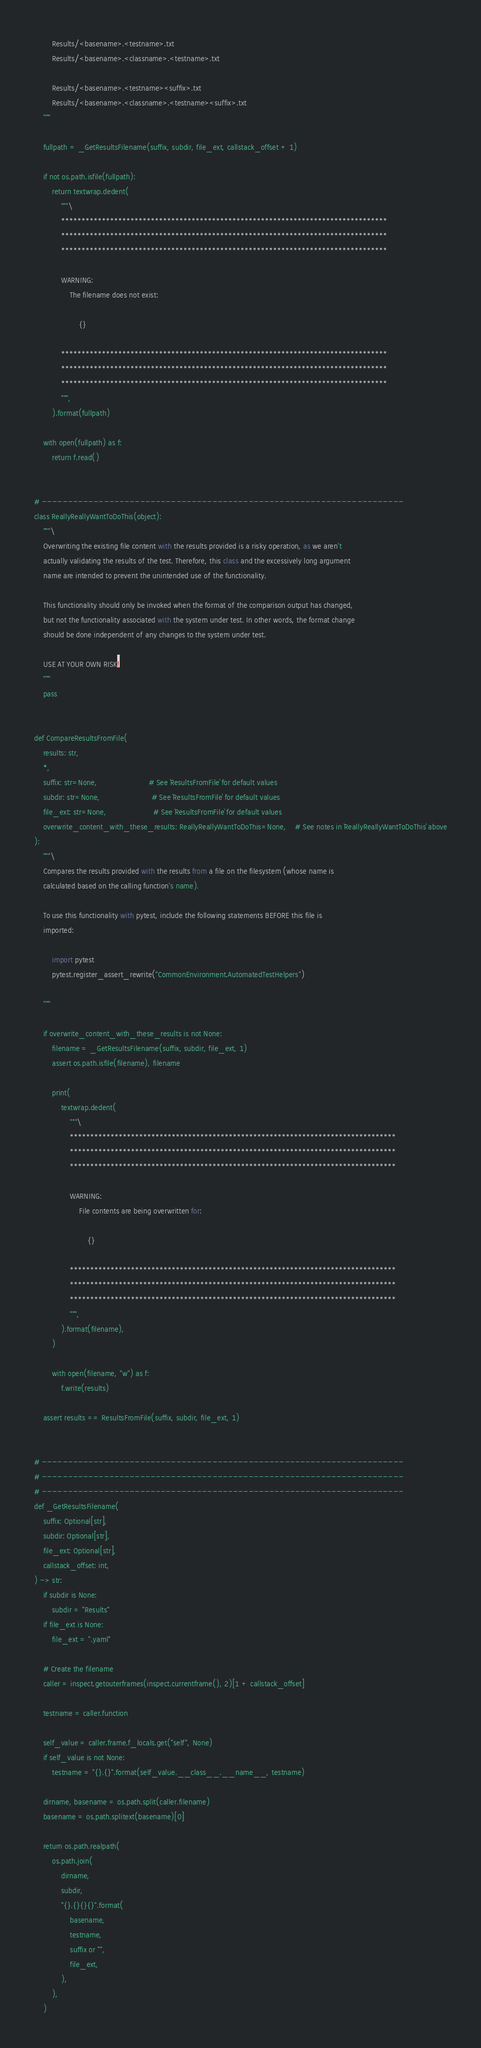<code> <loc_0><loc_0><loc_500><loc_500><_Python_>        Results/<basename>.<testname>.txt
        Results/<basename>.<classname>.<testname>.txt

        Results/<basename>.<testname><suffix>.txt
        Results/<basename>.<classname>.<testname><suffix>.txt
    """

    fullpath = _GetResultsFilename(suffix, subdir, file_ext, callstack_offset + 1)

    if not os.path.isfile(fullpath):
        return textwrap.dedent(
            """\
            ********************************************************************************
            ********************************************************************************
            ********************************************************************************

            WARNING:
                The filename does not exist:

                    {}

            ********************************************************************************
            ********************************************************************************
            ********************************************************************************
            """,
        ).format(fullpath)

    with open(fullpath) as f:
        return f.read()


# ----------------------------------------------------------------------
class ReallyReallyWantToDoThis(object):
    """\
    Overwriting the existing file content with the results provided is a risky operation, as we aren't
    actually validating the results of the test. Therefore, this class and the excessively long argument
    name are intended to prevent the unintended use of the functionality.

    This functionality should only be invoked when the format of the comparison output has changed,
    but not the functionality associated with the system under test. In other words, the format change
    should be done independent of any changes to the system under test.

    USE AT YOUR OWN RISK!
    """
    pass


def CompareResultsFromFile(
    results: str,
    *,
    suffix: str=None,                       # See `ResultsFromFile` for default values
    subdir: str=None,                       # See `ResultsFromFile` for default values
    file_ext: str=None,                     # See `ResultsFromFile` for default values
    overwrite_content_with_these_results: ReallyReallyWantToDoThis=None,    # See notes in `ReallyReallyWantToDoThis` above
):
    """\
    Compares the results provided with the results from a file on the filesystem (whose name is
    calculated based on the calling function's name).

    To use this functionality with pytest, include the following statements BEFORE this file is
    imported:

        import pytest
        pytest.register_assert_rewrite("CommonEnvironment.AutomatedTestHelpers")

    """

    if overwrite_content_with_these_results is not None:
        filename = _GetResultsFilename(suffix, subdir, file_ext, 1)
        assert os.path.isfile(filename), filename

        print(
            textwrap.dedent(
                """\
                ********************************************************************************
                ********************************************************************************
                ********************************************************************************

                WARNING:
                    File contents are being overwritten for:

                        {}

                ********************************************************************************
                ********************************************************************************
                ********************************************************************************
                """,
            ).format(filename),
        )

        with open(filename, "w") as f:
            f.write(results)

    assert results == ResultsFromFile(suffix, subdir, file_ext, 1)


# ----------------------------------------------------------------------
# ----------------------------------------------------------------------
# ----------------------------------------------------------------------
def _GetResultsFilename(
    suffix: Optional[str],
    subdir: Optional[str],
    file_ext: Optional[str],
    callstack_offset: int,
) -> str:
    if subdir is None:
        subdir = "Results"
    if file_ext is None:
        file_ext = ".yaml"

    # Create the filename
    caller = inspect.getouterframes(inspect.currentframe(), 2)[1 + callstack_offset]

    testname = caller.function

    self_value = caller.frame.f_locals.get("self", None)
    if self_value is not None:
        testname = "{}.{}".format(self_value.__class__.__name__, testname)

    dirname, basename = os.path.split(caller.filename)
    basename = os.path.splitext(basename)[0]

    return os.path.realpath(
        os.path.join(
            dirname,
            subdir,
            "{}.{}{}{}".format(
                basename,
                testname,
                suffix or "",
                file_ext,
            ),
        ),
    )
</code> 